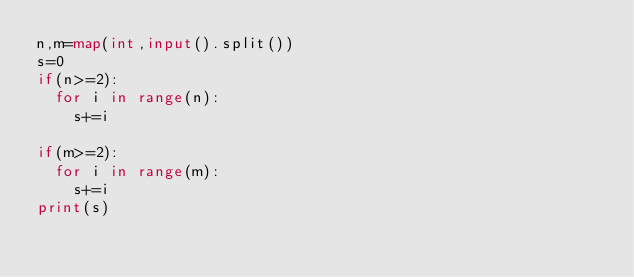Convert code to text. <code><loc_0><loc_0><loc_500><loc_500><_Python_>n,m=map(int,input().split())
s=0
if(n>=2):
  for i in range(n):
    s+=i
    
if(m>=2):
  for i in range(m):
    s+=i
print(s)</code> 